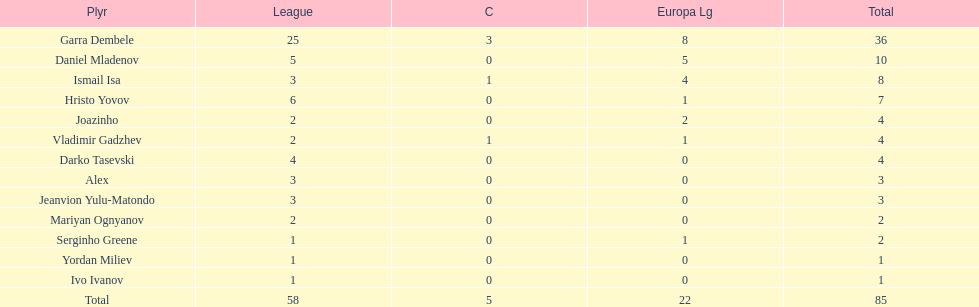Which total is higher, the europa league total or the league total? League. 